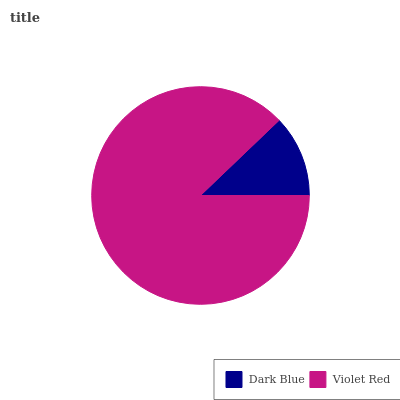Is Dark Blue the minimum?
Answer yes or no. Yes. Is Violet Red the maximum?
Answer yes or no. Yes. Is Violet Red the minimum?
Answer yes or no. No. Is Violet Red greater than Dark Blue?
Answer yes or no. Yes. Is Dark Blue less than Violet Red?
Answer yes or no. Yes. Is Dark Blue greater than Violet Red?
Answer yes or no. No. Is Violet Red less than Dark Blue?
Answer yes or no. No. Is Violet Red the high median?
Answer yes or no. Yes. Is Dark Blue the low median?
Answer yes or no. Yes. Is Dark Blue the high median?
Answer yes or no. No. Is Violet Red the low median?
Answer yes or no. No. 